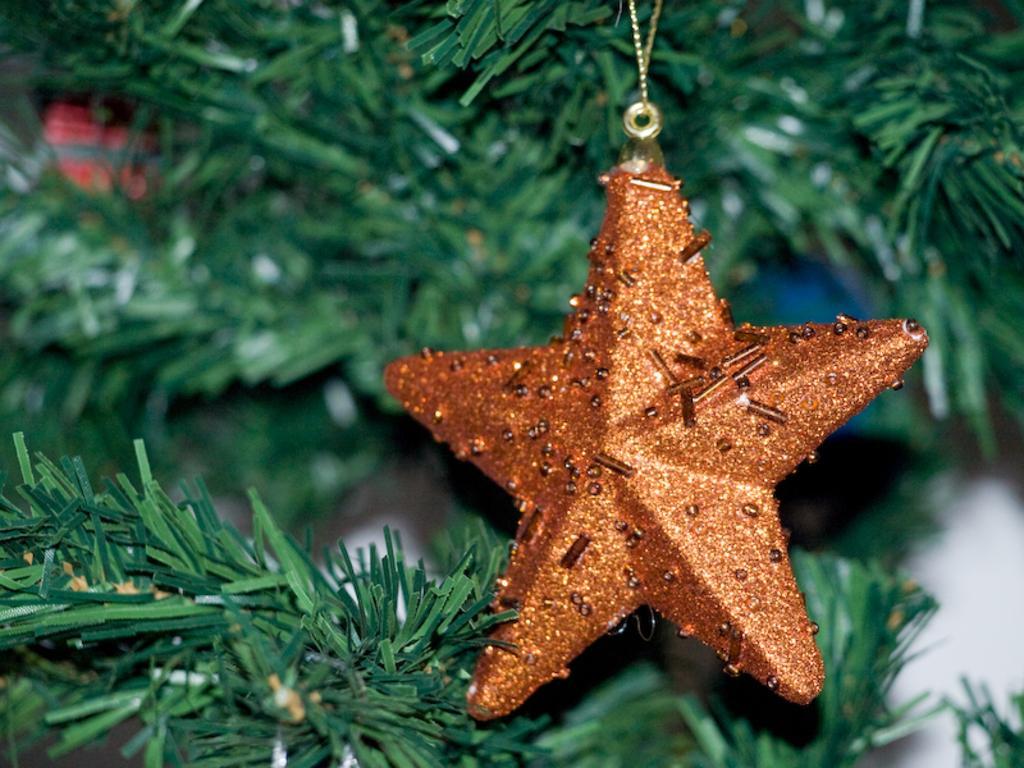Could you give a brief overview of what you see in this image? In this image there is a Christmas tree with a little star hanging to the stem of a tree. 